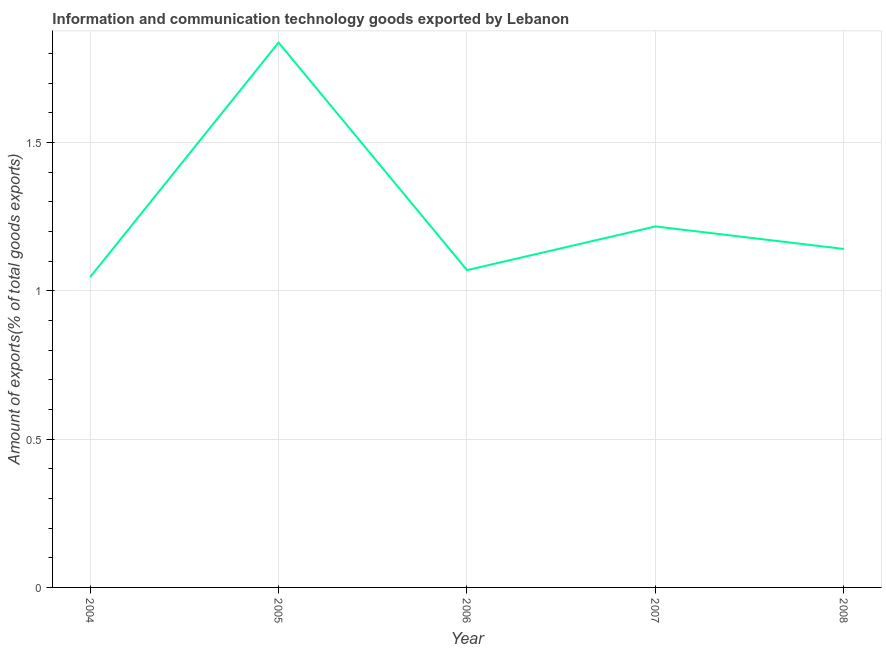What is the amount of ict goods exports in 2005?
Your answer should be very brief. 1.84. Across all years, what is the maximum amount of ict goods exports?
Your answer should be compact. 1.84. Across all years, what is the minimum amount of ict goods exports?
Make the answer very short. 1.05. In which year was the amount of ict goods exports maximum?
Your answer should be very brief. 2005. What is the sum of the amount of ict goods exports?
Keep it short and to the point. 6.31. What is the difference between the amount of ict goods exports in 2004 and 2006?
Offer a terse response. -0.02. What is the average amount of ict goods exports per year?
Make the answer very short. 1.26. What is the median amount of ict goods exports?
Give a very brief answer. 1.14. In how many years, is the amount of ict goods exports greater than 1.7 %?
Give a very brief answer. 1. Do a majority of the years between 2006 and 2008 (inclusive) have amount of ict goods exports greater than 0.9 %?
Your answer should be compact. Yes. What is the ratio of the amount of ict goods exports in 2005 to that in 2006?
Make the answer very short. 1.72. Is the amount of ict goods exports in 2004 less than that in 2005?
Make the answer very short. Yes. What is the difference between the highest and the second highest amount of ict goods exports?
Your answer should be very brief. 0.62. What is the difference between the highest and the lowest amount of ict goods exports?
Offer a terse response. 0.79. In how many years, is the amount of ict goods exports greater than the average amount of ict goods exports taken over all years?
Give a very brief answer. 1. What is the difference between two consecutive major ticks on the Y-axis?
Ensure brevity in your answer.  0.5. Are the values on the major ticks of Y-axis written in scientific E-notation?
Give a very brief answer. No. What is the title of the graph?
Ensure brevity in your answer.  Information and communication technology goods exported by Lebanon. What is the label or title of the X-axis?
Provide a succinct answer. Year. What is the label or title of the Y-axis?
Provide a short and direct response. Amount of exports(% of total goods exports). What is the Amount of exports(% of total goods exports) in 2004?
Offer a very short reply. 1.05. What is the Amount of exports(% of total goods exports) of 2005?
Provide a short and direct response. 1.84. What is the Amount of exports(% of total goods exports) in 2006?
Offer a terse response. 1.07. What is the Amount of exports(% of total goods exports) in 2007?
Keep it short and to the point. 1.22. What is the Amount of exports(% of total goods exports) in 2008?
Give a very brief answer. 1.14. What is the difference between the Amount of exports(% of total goods exports) in 2004 and 2005?
Ensure brevity in your answer.  -0.79. What is the difference between the Amount of exports(% of total goods exports) in 2004 and 2006?
Provide a succinct answer. -0.02. What is the difference between the Amount of exports(% of total goods exports) in 2004 and 2007?
Offer a terse response. -0.17. What is the difference between the Amount of exports(% of total goods exports) in 2004 and 2008?
Provide a succinct answer. -0.09. What is the difference between the Amount of exports(% of total goods exports) in 2005 and 2006?
Give a very brief answer. 0.77. What is the difference between the Amount of exports(% of total goods exports) in 2005 and 2007?
Give a very brief answer. 0.62. What is the difference between the Amount of exports(% of total goods exports) in 2005 and 2008?
Keep it short and to the point. 0.7. What is the difference between the Amount of exports(% of total goods exports) in 2006 and 2007?
Provide a succinct answer. -0.15. What is the difference between the Amount of exports(% of total goods exports) in 2006 and 2008?
Ensure brevity in your answer.  -0.07. What is the difference between the Amount of exports(% of total goods exports) in 2007 and 2008?
Ensure brevity in your answer.  0.08. What is the ratio of the Amount of exports(% of total goods exports) in 2004 to that in 2005?
Your response must be concise. 0.57. What is the ratio of the Amount of exports(% of total goods exports) in 2004 to that in 2006?
Offer a terse response. 0.98. What is the ratio of the Amount of exports(% of total goods exports) in 2004 to that in 2007?
Make the answer very short. 0.86. What is the ratio of the Amount of exports(% of total goods exports) in 2004 to that in 2008?
Offer a very short reply. 0.92. What is the ratio of the Amount of exports(% of total goods exports) in 2005 to that in 2006?
Offer a terse response. 1.72. What is the ratio of the Amount of exports(% of total goods exports) in 2005 to that in 2007?
Provide a short and direct response. 1.51. What is the ratio of the Amount of exports(% of total goods exports) in 2005 to that in 2008?
Offer a very short reply. 1.61. What is the ratio of the Amount of exports(% of total goods exports) in 2006 to that in 2007?
Offer a terse response. 0.88. What is the ratio of the Amount of exports(% of total goods exports) in 2006 to that in 2008?
Your response must be concise. 0.94. What is the ratio of the Amount of exports(% of total goods exports) in 2007 to that in 2008?
Provide a succinct answer. 1.07. 